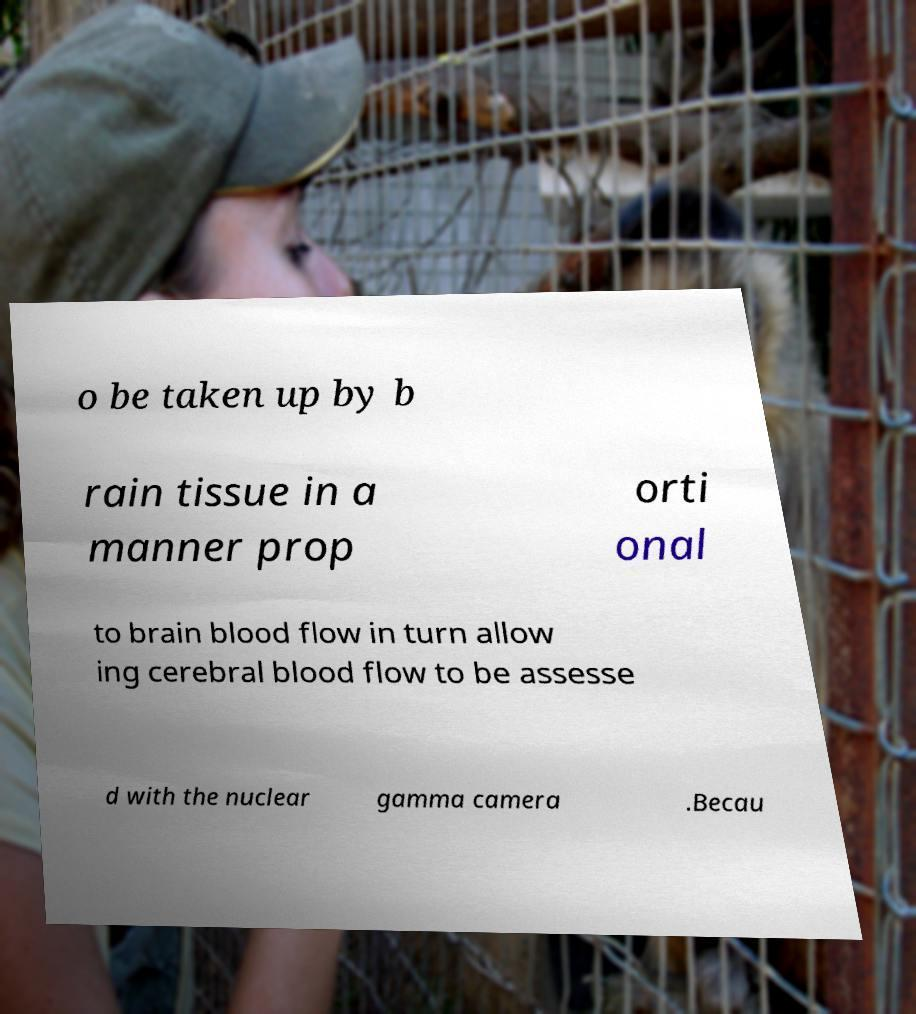What messages or text are displayed in this image? I need them in a readable, typed format. o be taken up by b rain tissue in a manner prop orti onal to brain blood flow in turn allow ing cerebral blood flow to be assesse d with the nuclear gamma camera .Becau 